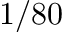<formula> <loc_0><loc_0><loc_500><loc_500>1 / 8 0</formula> 